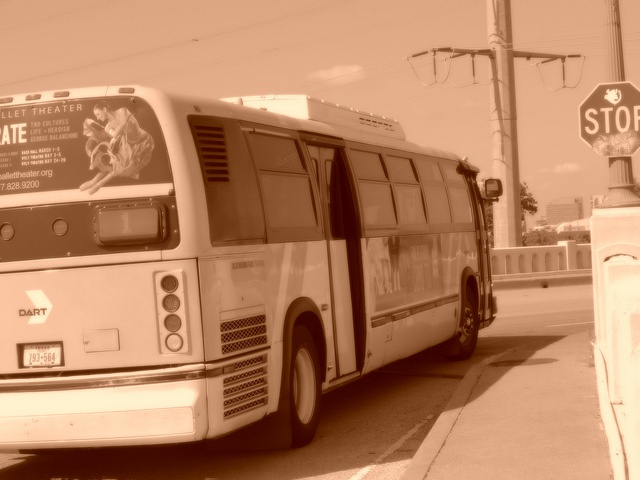Describe the objects in this image and their specific colors. I can see bus in tan, salmon, brown, and maroon tones, people in tan and salmon tones, and stop sign in tan and salmon tones in this image. 